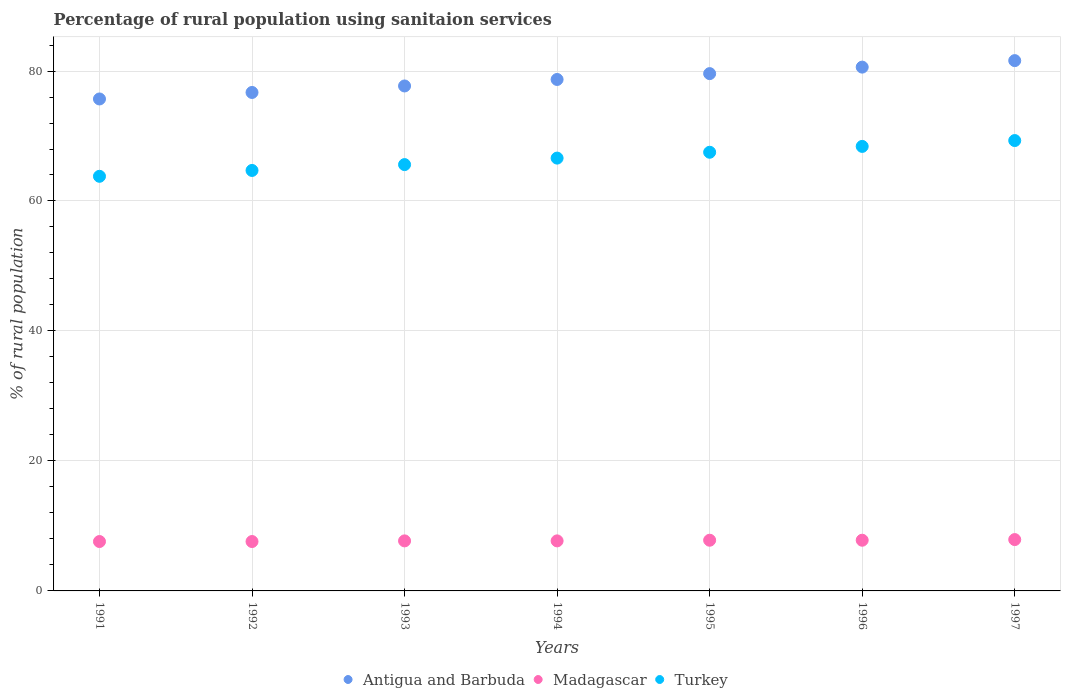How many different coloured dotlines are there?
Give a very brief answer. 3. Is the number of dotlines equal to the number of legend labels?
Provide a succinct answer. Yes. What is the percentage of rural population using sanitaion services in Antigua and Barbuda in 1992?
Your response must be concise. 76.7. Across all years, what is the maximum percentage of rural population using sanitaion services in Turkey?
Your response must be concise. 69.3. Across all years, what is the minimum percentage of rural population using sanitaion services in Turkey?
Keep it short and to the point. 63.8. In which year was the percentage of rural population using sanitaion services in Turkey maximum?
Keep it short and to the point. 1997. What is the total percentage of rural population using sanitaion services in Turkey in the graph?
Offer a terse response. 465.9. What is the difference between the percentage of rural population using sanitaion services in Antigua and Barbuda in 1991 and that in 1995?
Offer a terse response. -3.9. What is the difference between the percentage of rural population using sanitaion services in Antigua and Barbuda in 1992 and the percentage of rural population using sanitaion services in Madagascar in 1997?
Ensure brevity in your answer.  68.8. What is the average percentage of rural population using sanitaion services in Turkey per year?
Provide a short and direct response. 66.56. In the year 1992, what is the difference between the percentage of rural population using sanitaion services in Antigua and Barbuda and percentage of rural population using sanitaion services in Madagascar?
Provide a short and direct response. 69.1. In how many years, is the percentage of rural population using sanitaion services in Turkey greater than 32 %?
Your answer should be compact. 7. What is the ratio of the percentage of rural population using sanitaion services in Antigua and Barbuda in 1993 to that in 1997?
Provide a short and direct response. 0.95. What is the difference between the highest and the lowest percentage of rural population using sanitaion services in Turkey?
Offer a terse response. 5.5. In how many years, is the percentage of rural population using sanitaion services in Turkey greater than the average percentage of rural population using sanitaion services in Turkey taken over all years?
Keep it short and to the point. 4. Is it the case that in every year, the sum of the percentage of rural population using sanitaion services in Madagascar and percentage of rural population using sanitaion services in Antigua and Barbuda  is greater than the percentage of rural population using sanitaion services in Turkey?
Offer a very short reply. Yes. Does the percentage of rural population using sanitaion services in Madagascar monotonically increase over the years?
Ensure brevity in your answer.  No. Is the percentage of rural population using sanitaion services in Turkey strictly greater than the percentage of rural population using sanitaion services in Madagascar over the years?
Your answer should be very brief. Yes. Is the percentage of rural population using sanitaion services in Madagascar strictly less than the percentage of rural population using sanitaion services in Turkey over the years?
Make the answer very short. Yes. How many dotlines are there?
Offer a terse response. 3. What is the difference between two consecutive major ticks on the Y-axis?
Your answer should be compact. 20. Does the graph contain any zero values?
Make the answer very short. No. Where does the legend appear in the graph?
Provide a succinct answer. Bottom center. How are the legend labels stacked?
Ensure brevity in your answer.  Horizontal. What is the title of the graph?
Your answer should be very brief. Percentage of rural population using sanitaion services. Does "Swaziland" appear as one of the legend labels in the graph?
Your answer should be very brief. No. What is the label or title of the Y-axis?
Your answer should be very brief. % of rural population. What is the % of rural population of Antigua and Barbuda in 1991?
Keep it short and to the point. 75.7. What is the % of rural population in Madagascar in 1991?
Ensure brevity in your answer.  7.6. What is the % of rural population of Turkey in 1991?
Offer a very short reply. 63.8. What is the % of rural population in Antigua and Barbuda in 1992?
Ensure brevity in your answer.  76.7. What is the % of rural population of Turkey in 1992?
Give a very brief answer. 64.7. What is the % of rural population in Antigua and Barbuda in 1993?
Your answer should be compact. 77.7. What is the % of rural population of Madagascar in 1993?
Offer a very short reply. 7.7. What is the % of rural population of Turkey in 1993?
Provide a short and direct response. 65.6. What is the % of rural population of Antigua and Barbuda in 1994?
Provide a succinct answer. 78.7. What is the % of rural population in Turkey in 1994?
Your answer should be compact. 66.6. What is the % of rural population in Antigua and Barbuda in 1995?
Keep it short and to the point. 79.6. What is the % of rural population of Turkey in 1995?
Your response must be concise. 67.5. What is the % of rural population of Antigua and Barbuda in 1996?
Offer a very short reply. 80.6. What is the % of rural population of Turkey in 1996?
Your response must be concise. 68.4. What is the % of rural population in Antigua and Barbuda in 1997?
Offer a terse response. 81.6. What is the % of rural population of Madagascar in 1997?
Provide a short and direct response. 7.9. What is the % of rural population in Turkey in 1997?
Provide a short and direct response. 69.3. Across all years, what is the maximum % of rural population in Antigua and Barbuda?
Your answer should be compact. 81.6. Across all years, what is the maximum % of rural population in Turkey?
Offer a terse response. 69.3. Across all years, what is the minimum % of rural population in Antigua and Barbuda?
Keep it short and to the point. 75.7. Across all years, what is the minimum % of rural population in Madagascar?
Keep it short and to the point. 7.6. Across all years, what is the minimum % of rural population of Turkey?
Your answer should be compact. 63.8. What is the total % of rural population of Antigua and Barbuda in the graph?
Ensure brevity in your answer.  550.6. What is the total % of rural population of Madagascar in the graph?
Provide a short and direct response. 54.1. What is the total % of rural population in Turkey in the graph?
Provide a short and direct response. 465.9. What is the difference between the % of rural population in Madagascar in 1991 and that in 1992?
Your answer should be very brief. 0. What is the difference between the % of rural population of Turkey in 1991 and that in 1992?
Your response must be concise. -0.9. What is the difference between the % of rural population of Antigua and Barbuda in 1991 and that in 1993?
Your answer should be very brief. -2. What is the difference between the % of rural population of Antigua and Barbuda in 1991 and that in 1994?
Your answer should be very brief. -3. What is the difference between the % of rural population of Turkey in 1991 and that in 1994?
Ensure brevity in your answer.  -2.8. What is the difference between the % of rural population of Madagascar in 1991 and that in 1995?
Ensure brevity in your answer.  -0.2. What is the difference between the % of rural population in Turkey in 1991 and that in 1995?
Your response must be concise. -3.7. What is the difference between the % of rural population in Turkey in 1991 and that in 1996?
Make the answer very short. -4.6. What is the difference between the % of rural population in Turkey in 1991 and that in 1997?
Your answer should be very brief. -5.5. What is the difference between the % of rural population in Antigua and Barbuda in 1992 and that in 1993?
Provide a short and direct response. -1. What is the difference between the % of rural population in Turkey in 1992 and that in 1993?
Keep it short and to the point. -0.9. What is the difference between the % of rural population of Antigua and Barbuda in 1992 and that in 1994?
Make the answer very short. -2. What is the difference between the % of rural population in Turkey in 1992 and that in 1994?
Provide a short and direct response. -1.9. What is the difference between the % of rural population of Antigua and Barbuda in 1992 and that in 1995?
Give a very brief answer. -2.9. What is the difference between the % of rural population in Madagascar in 1992 and that in 1995?
Your response must be concise. -0.2. What is the difference between the % of rural population of Turkey in 1992 and that in 1995?
Provide a short and direct response. -2.8. What is the difference between the % of rural population in Antigua and Barbuda in 1992 and that in 1996?
Your answer should be compact. -3.9. What is the difference between the % of rural population of Madagascar in 1992 and that in 1996?
Your answer should be compact. -0.2. What is the difference between the % of rural population of Turkey in 1992 and that in 1996?
Your answer should be compact. -3.7. What is the difference between the % of rural population of Antigua and Barbuda in 1993 and that in 1994?
Offer a terse response. -1. What is the difference between the % of rural population of Madagascar in 1993 and that in 1994?
Your answer should be very brief. 0. What is the difference between the % of rural population in Madagascar in 1993 and that in 1995?
Provide a short and direct response. -0.1. What is the difference between the % of rural population of Turkey in 1993 and that in 1995?
Your answer should be compact. -1.9. What is the difference between the % of rural population of Turkey in 1993 and that in 1997?
Ensure brevity in your answer.  -3.7. What is the difference between the % of rural population in Madagascar in 1994 and that in 1995?
Provide a succinct answer. -0.1. What is the difference between the % of rural population in Turkey in 1994 and that in 1996?
Provide a short and direct response. -1.8. What is the difference between the % of rural population of Antigua and Barbuda in 1994 and that in 1997?
Your response must be concise. -2.9. What is the difference between the % of rural population of Turkey in 1994 and that in 1997?
Provide a succinct answer. -2.7. What is the difference between the % of rural population in Turkey in 1995 and that in 1996?
Provide a succinct answer. -0.9. What is the difference between the % of rural population of Antigua and Barbuda in 1995 and that in 1997?
Your answer should be compact. -2. What is the difference between the % of rural population of Madagascar in 1995 and that in 1997?
Offer a very short reply. -0.1. What is the difference between the % of rural population of Turkey in 1996 and that in 1997?
Ensure brevity in your answer.  -0.9. What is the difference between the % of rural population of Antigua and Barbuda in 1991 and the % of rural population of Madagascar in 1992?
Provide a succinct answer. 68.1. What is the difference between the % of rural population of Madagascar in 1991 and the % of rural population of Turkey in 1992?
Offer a very short reply. -57.1. What is the difference between the % of rural population in Antigua and Barbuda in 1991 and the % of rural population in Madagascar in 1993?
Offer a terse response. 68. What is the difference between the % of rural population in Madagascar in 1991 and the % of rural population in Turkey in 1993?
Ensure brevity in your answer.  -58. What is the difference between the % of rural population in Antigua and Barbuda in 1991 and the % of rural population in Madagascar in 1994?
Provide a succinct answer. 68. What is the difference between the % of rural population of Madagascar in 1991 and the % of rural population of Turkey in 1994?
Your answer should be compact. -59. What is the difference between the % of rural population in Antigua and Barbuda in 1991 and the % of rural population in Madagascar in 1995?
Offer a terse response. 67.9. What is the difference between the % of rural population in Antigua and Barbuda in 1991 and the % of rural population in Turkey in 1995?
Ensure brevity in your answer.  8.2. What is the difference between the % of rural population in Madagascar in 1991 and the % of rural population in Turkey in 1995?
Your response must be concise. -59.9. What is the difference between the % of rural population of Antigua and Barbuda in 1991 and the % of rural population of Madagascar in 1996?
Ensure brevity in your answer.  67.9. What is the difference between the % of rural population in Madagascar in 1991 and the % of rural population in Turkey in 1996?
Ensure brevity in your answer.  -60.8. What is the difference between the % of rural population in Antigua and Barbuda in 1991 and the % of rural population in Madagascar in 1997?
Provide a succinct answer. 67.8. What is the difference between the % of rural population in Antigua and Barbuda in 1991 and the % of rural population in Turkey in 1997?
Offer a terse response. 6.4. What is the difference between the % of rural population in Madagascar in 1991 and the % of rural population in Turkey in 1997?
Offer a very short reply. -61.7. What is the difference between the % of rural population of Antigua and Barbuda in 1992 and the % of rural population of Madagascar in 1993?
Keep it short and to the point. 69. What is the difference between the % of rural population in Antigua and Barbuda in 1992 and the % of rural population in Turkey in 1993?
Your answer should be compact. 11.1. What is the difference between the % of rural population in Madagascar in 1992 and the % of rural population in Turkey in 1993?
Provide a short and direct response. -58. What is the difference between the % of rural population of Antigua and Barbuda in 1992 and the % of rural population of Madagascar in 1994?
Give a very brief answer. 69. What is the difference between the % of rural population of Madagascar in 1992 and the % of rural population of Turkey in 1994?
Your answer should be compact. -59. What is the difference between the % of rural population in Antigua and Barbuda in 1992 and the % of rural population in Madagascar in 1995?
Make the answer very short. 68.9. What is the difference between the % of rural population of Madagascar in 1992 and the % of rural population of Turkey in 1995?
Your answer should be very brief. -59.9. What is the difference between the % of rural population of Antigua and Barbuda in 1992 and the % of rural population of Madagascar in 1996?
Your answer should be compact. 68.9. What is the difference between the % of rural population in Madagascar in 1992 and the % of rural population in Turkey in 1996?
Give a very brief answer. -60.8. What is the difference between the % of rural population of Antigua and Barbuda in 1992 and the % of rural population of Madagascar in 1997?
Provide a short and direct response. 68.8. What is the difference between the % of rural population of Madagascar in 1992 and the % of rural population of Turkey in 1997?
Your answer should be compact. -61.7. What is the difference between the % of rural population of Antigua and Barbuda in 1993 and the % of rural population of Madagascar in 1994?
Ensure brevity in your answer.  70. What is the difference between the % of rural population in Antigua and Barbuda in 1993 and the % of rural population in Turkey in 1994?
Offer a terse response. 11.1. What is the difference between the % of rural population of Madagascar in 1993 and the % of rural population of Turkey in 1994?
Provide a short and direct response. -58.9. What is the difference between the % of rural population in Antigua and Barbuda in 1993 and the % of rural population in Madagascar in 1995?
Your response must be concise. 69.9. What is the difference between the % of rural population in Antigua and Barbuda in 1993 and the % of rural population in Turkey in 1995?
Keep it short and to the point. 10.2. What is the difference between the % of rural population in Madagascar in 1993 and the % of rural population in Turkey in 1995?
Offer a terse response. -59.8. What is the difference between the % of rural population in Antigua and Barbuda in 1993 and the % of rural population in Madagascar in 1996?
Offer a very short reply. 69.9. What is the difference between the % of rural population of Antigua and Barbuda in 1993 and the % of rural population of Turkey in 1996?
Provide a succinct answer. 9.3. What is the difference between the % of rural population in Madagascar in 1993 and the % of rural population in Turkey in 1996?
Offer a terse response. -60.7. What is the difference between the % of rural population of Antigua and Barbuda in 1993 and the % of rural population of Madagascar in 1997?
Offer a very short reply. 69.8. What is the difference between the % of rural population in Antigua and Barbuda in 1993 and the % of rural population in Turkey in 1997?
Your response must be concise. 8.4. What is the difference between the % of rural population in Madagascar in 1993 and the % of rural population in Turkey in 1997?
Provide a short and direct response. -61.6. What is the difference between the % of rural population of Antigua and Barbuda in 1994 and the % of rural population of Madagascar in 1995?
Offer a very short reply. 70.9. What is the difference between the % of rural population of Madagascar in 1994 and the % of rural population of Turkey in 1995?
Provide a short and direct response. -59.8. What is the difference between the % of rural population of Antigua and Barbuda in 1994 and the % of rural population of Madagascar in 1996?
Your answer should be very brief. 70.9. What is the difference between the % of rural population of Antigua and Barbuda in 1994 and the % of rural population of Turkey in 1996?
Keep it short and to the point. 10.3. What is the difference between the % of rural population of Madagascar in 1994 and the % of rural population of Turkey in 1996?
Your answer should be compact. -60.7. What is the difference between the % of rural population in Antigua and Barbuda in 1994 and the % of rural population in Madagascar in 1997?
Provide a short and direct response. 70.8. What is the difference between the % of rural population of Antigua and Barbuda in 1994 and the % of rural population of Turkey in 1997?
Keep it short and to the point. 9.4. What is the difference between the % of rural population in Madagascar in 1994 and the % of rural population in Turkey in 1997?
Keep it short and to the point. -61.6. What is the difference between the % of rural population of Antigua and Barbuda in 1995 and the % of rural population of Madagascar in 1996?
Your response must be concise. 71.8. What is the difference between the % of rural population of Madagascar in 1995 and the % of rural population of Turkey in 1996?
Offer a very short reply. -60.6. What is the difference between the % of rural population of Antigua and Barbuda in 1995 and the % of rural population of Madagascar in 1997?
Ensure brevity in your answer.  71.7. What is the difference between the % of rural population of Antigua and Barbuda in 1995 and the % of rural population of Turkey in 1997?
Provide a short and direct response. 10.3. What is the difference between the % of rural population of Madagascar in 1995 and the % of rural population of Turkey in 1997?
Ensure brevity in your answer.  -61.5. What is the difference between the % of rural population in Antigua and Barbuda in 1996 and the % of rural population in Madagascar in 1997?
Give a very brief answer. 72.7. What is the difference between the % of rural population of Antigua and Barbuda in 1996 and the % of rural population of Turkey in 1997?
Your answer should be compact. 11.3. What is the difference between the % of rural population in Madagascar in 1996 and the % of rural population in Turkey in 1997?
Make the answer very short. -61.5. What is the average % of rural population in Antigua and Barbuda per year?
Your answer should be compact. 78.66. What is the average % of rural population in Madagascar per year?
Give a very brief answer. 7.73. What is the average % of rural population of Turkey per year?
Your answer should be very brief. 66.56. In the year 1991, what is the difference between the % of rural population in Antigua and Barbuda and % of rural population in Madagascar?
Ensure brevity in your answer.  68.1. In the year 1991, what is the difference between the % of rural population in Madagascar and % of rural population in Turkey?
Ensure brevity in your answer.  -56.2. In the year 1992, what is the difference between the % of rural population of Antigua and Barbuda and % of rural population of Madagascar?
Your answer should be very brief. 69.1. In the year 1992, what is the difference between the % of rural population of Antigua and Barbuda and % of rural population of Turkey?
Your answer should be very brief. 12. In the year 1992, what is the difference between the % of rural population in Madagascar and % of rural population in Turkey?
Provide a short and direct response. -57.1. In the year 1993, what is the difference between the % of rural population in Antigua and Barbuda and % of rural population in Madagascar?
Your answer should be compact. 70. In the year 1993, what is the difference between the % of rural population of Antigua and Barbuda and % of rural population of Turkey?
Provide a succinct answer. 12.1. In the year 1993, what is the difference between the % of rural population in Madagascar and % of rural population in Turkey?
Provide a short and direct response. -57.9. In the year 1994, what is the difference between the % of rural population in Antigua and Barbuda and % of rural population in Madagascar?
Provide a succinct answer. 71. In the year 1994, what is the difference between the % of rural population in Antigua and Barbuda and % of rural population in Turkey?
Provide a short and direct response. 12.1. In the year 1994, what is the difference between the % of rural population of Madagascar and % of rural population of Turkey?
Make the answer very short. -58.9. In the year 1995, what is the difference between the % of rural population of Antigua and Barbuda and % of rural population of Madagascar?
Make the answer very short. 71.8. In the year 1995, what is the difference between the % of rural population of Antigua and Barbuda and % of rural population of Turkey?
Your answer should be compact. 12.1. In the year 1995, what is the difference between the % of rural population in Madagascar and % of rural population in Turkey?
Your answer should be very brief. -59.7. In the year 1996, what is the difference between the % of rural population of Antigua and Barbuda and % of rural population of Madagascar?
Provide a short and direct response. 72.8. In the year 1996, what is the difference between the % of rural population in Madagascar and % of rural population in Turkey?
Your answer should be compact. -60.6. In the year 1997, what is the difference between the % of rural population of Antigua and Barbuda and % of rural population of Madagascar?
Make the answer very short. 73.7. In the year 1997, what is the difference between the % of rural population of Madagascar and % of rural population of Turkey?
Ensure brevity in your answer.  -61.4. What is the ratio of the % of rural population in Turkey in 1991 to that in 1992?
Keep it short and to the point. 0.99. What is the ratio of the % of rural population of Antigua and Barbuda in 1991 to that in 1993?
Keep it short and to the point. 0.97. What is the ratio of the % of rural population in Madagascar in 1991 to that in 1993?
Keep it short and to the point. 0.99. What is the ratio of the % of rural population of Turkey in 1991 to that in 1993?
Provide a succinct answer. 0.97. What is the ratio of the % of rural population of Antigua and Barbuda in 1991 to that in 1994?
Your response must be concise. 0.96. What is the ratio of the % of rural population in Turkey in 1991 to that in 1994?
Keep it short and to the point. 0.96. What is the ratio of the % of rural population of Antigua and Barbuda in 1991 to that in 1995?
Your response must be concise. 0.95. What is the ratio of the % of rural population in Madagascar in 1991 to that in 1995?
Keep it short and to the point. 0.97. What is the ratio of the % of rural population in Turkey in 1991 to that in 1995?
Your answer should be compact. 0.95. What is the ratio of the % of rural population of Antigua and Barbuda in 1991 to that in 1996?
Make the answer very short. 0.94. What is the ratio of the % of rural population in Madagascar in 1991 to that in 1996?
Your response must be concise. 0.97. What is the ratio of the % of rural population of Turkey in 1991 to that in 1996?
Provide a succinct answer. 0.93. What is the ratio of the % of rural population of Antigua and Barbuda in 1991 to that in 1997?
Offer a terse response. 0.93. What is the ratio of the % of rural population in Turkey in 1991 to that in 1997?
Give a very brief answer. 0.92. What is the ratio of the % of rural population of Antigua and Barbuda in 1992 to that in 1993?
Your answer should be compact. 0.99. What is the ratio of the % of rural population of Madagascar in 1992 to that in 1993?
Ensure brevity in your answer.  0.99. What is the ratio of the % of rural population in Turkey in 1992 to that in 1993?
Offer a terse response. 0.99. What is the ratio of the % of rural population in Antigua and Barbuda in 1992 to that in 1994?
Your answer should be compact. 0.97. What is the ratio of the % of rural population in Turkey in 1992 to that in 1994?
Your response must be concise. 0.97. What is the ratio of the % of rural population in Antigua and Barbuda in 1992 to that in 1995?
Your answer should be very brief. 0.96. What is the ratio of the % of rural population in Madagascar in 1992 to that in 1995?
Your answer should be compact. 0.97. What is the ratio of the % of rural population in Turkey in 1992 to that in 1995?
Provide a succinct answer. 0.96. What is the ratio of the % of rural population in Antigua and Barbuda in 1992 to that in 1996?
Keep it short and to the point. 0.95. What is the ratio of the % of rural population of Madagascar in 1992 to that in 1996?
Ensure brevity in your answer.  0.97. What is the ratio of the % of rural population of Turkey in 1992 to that in 1996?
Make the answer very short. 0.95. What is the ratio of the % of rural population of Madagascar in 1992 to that in 1997?
Make the answer very short. 0.96. What is the ratio of the % of rural population of Turkey in 1992 to that in 1997?
Your answer should be compact. 0.93. What is the ratio of the % of rural population in Antigua and Barbuda in 1993 to that in 1994?
Offer a terse response. 0.99. What is the ratio of the % of rural population of Antigua and Barbuda in 1993 to that in 1995?
Keep it short and to the point. 0.98. What is the ratio of the % of rural population of Madagascar in 1993 to that in 1995?
Offer a very short reply. 0.99. What is the ratio of the % of rural population in Turkey in 1993 to that in 1995?
Your answer should be very brief. 0.97. What is the ratio of the % of rural population in Antigua and Barbuda in 1993 to that in 1996?
Ensure brevity in your answer.  0.96. What is the ratio of the % of rural population of Madagascar in 1993 to that in 1996?
Ensure brevity in your answer.  0.99. What is the ratio of the % of rural population of Turkey in 1993 to that in 1996?
Ensure brevity in your answer.  0.96. What is the ratio of the % of rural population in Antigua and Barbuda in 1993 to that in 1997?
Your response must be concise. 0.95. What is the ratio of the % of rural population in Madagascar in 1993 to that in 1997?
Offer a very short reply. 0.97. What is the ratio of the % of rural population of Turkey in 1993 to that in 1997?
Provide a succinct answer. 0.95. What is the ratio of the % of rural population in Antigua and Barbuda in 1994 to that in 1995?
Offer a very short reply. 0.99. What is the ratio of the % of rural population in Madagascar in 1994 to that in 1995?
Ensure brevity in your answer.  0.99. What is the ratio of the % of rural population in Turkey in 1994 to that in 1995?
Provide a succinct answer. 0.99. What is the ratio of the % of rural population in Antigua and Barbuda in 1994 to that in 1996?
Offer a very short reply. 0.98. What is the ratio of the % of rural population in Madagascar in 1994 to that in 1996?
Make the answer very short. 0.99. What is the ratio of the % of rural population of Turkey in 1994 to that in 1996?
Offer a terse response. 0.97. What is the ratio of the % of rural population in Antigua and Barbuda in 1994 to that in 1997?
Ensure brevity in your answer.  0.96. What is the ratio of the % of rural population of Madagascar in 1994 to that in 1997?
Your answer should be very brief. 0.97. What is the ratio of the % of rural population of Antigua and Barbuda in 1995 to that in 1996?
Make the answer very short. 0.99. What is the ratio of the % of rural population of Turkey in 1995 to that in 1996?
Your response must be concise. 0.99. What is the ratio of the % of rural population of Antigua and Barbuda in 1995 to that in 1997?
Make the answer very short. 0.98. What is the ratio of the % of rural population of Madagascar in 1995 to that in 1997?
Keep it short and to the point. 0.99. What is the ratio of the % of rural population in Madagascar in 1996 to that in 1997?
Offer a very short reply. 0.99. What is the ratio of the % of rural population of Turkey in 1996 to that in 1997?
Make the answer very short. 0.99. What is the difference between the highest and the lowest % of rural population of Antigua and Barbuda?
Provide a succinct answer. 5.9. 